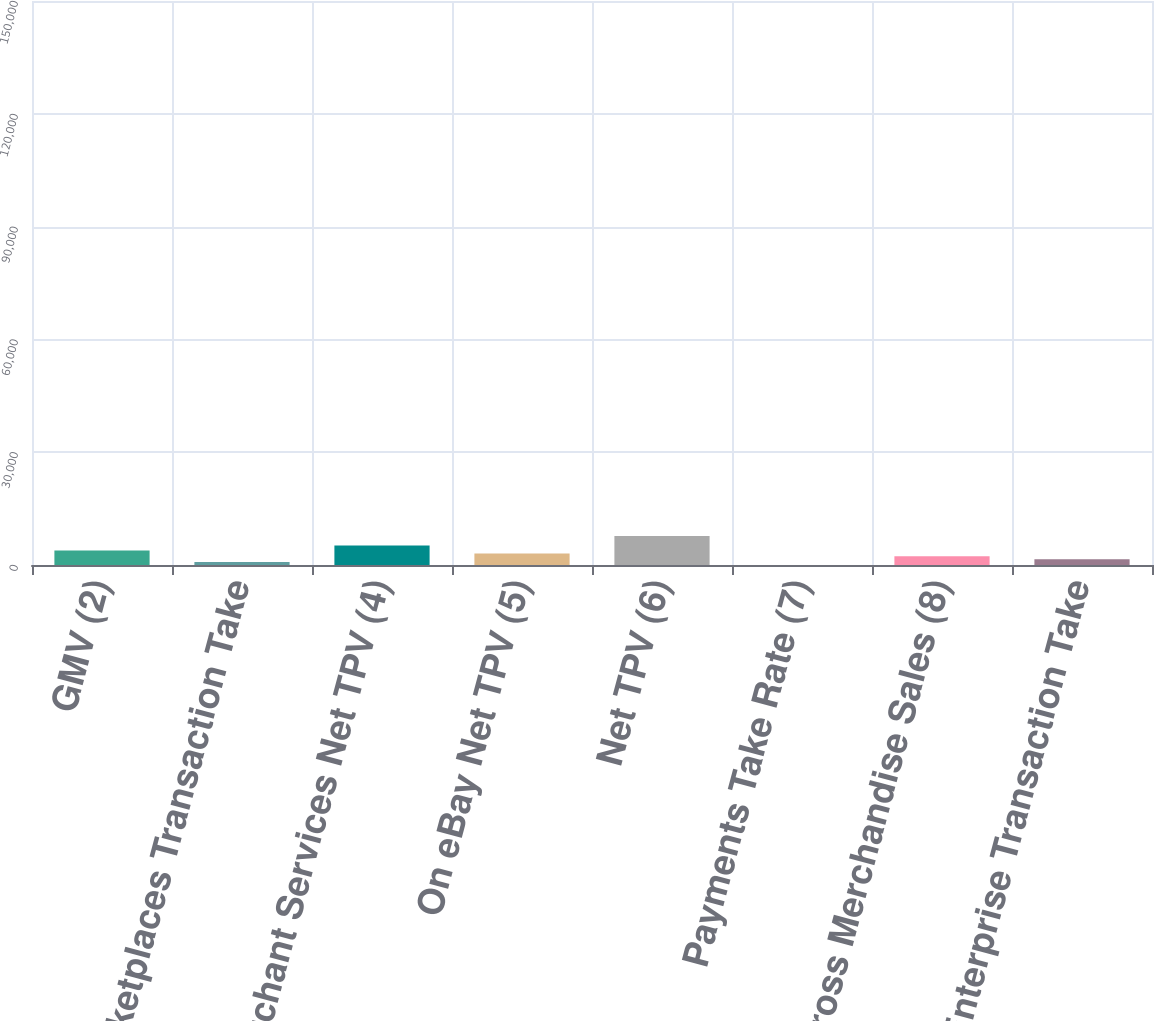Convert chart to OTSL. <chart><loc_0><loc_0><loc_500><loc_500><bar_chart><fcel>GMV (2)<fcel>Marketplaces Transaction Take<fcel>Merchant Services Net TPV (4)<fcel>On eBay Net TPV (5)<fcel>Net TPV (6)<fcel>Payments Take Rate (7)<fcel>Gross Merchandise Sales (8)<fcel>Enterprise Transaction Take<nl><fcel>72470.4<fcel>14497.2<fcel>97277<fcel>57977.1<fcel>144937<fcel>3.85<fcel>43483.8<fcel>28990.5<nl></chart> 